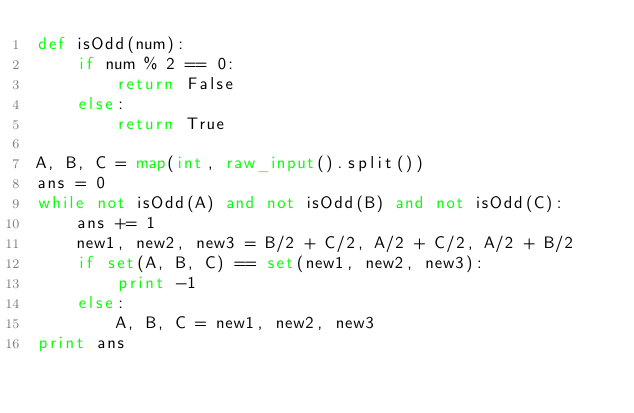<code> <loc_0><loc_0><loc_500><loc_500><_Python_>def isOdd(num):
	if num % 2 == 0:
		return False
	else:
		return True

A, B, C = map(int, raw_input().split())
ans = 0
while not isOdd(A) and not isOdd(B) and not isOdd(C):
	ans += 1
	new1, new2, new3 = B/2 + C/2, A/2 + C/2, A/2 + B/2
	if set(A, B, C) == set(new1, new2, new3):
		print -1
	else:
		A, B, C = new1, new2, new3
print ans
</code> 